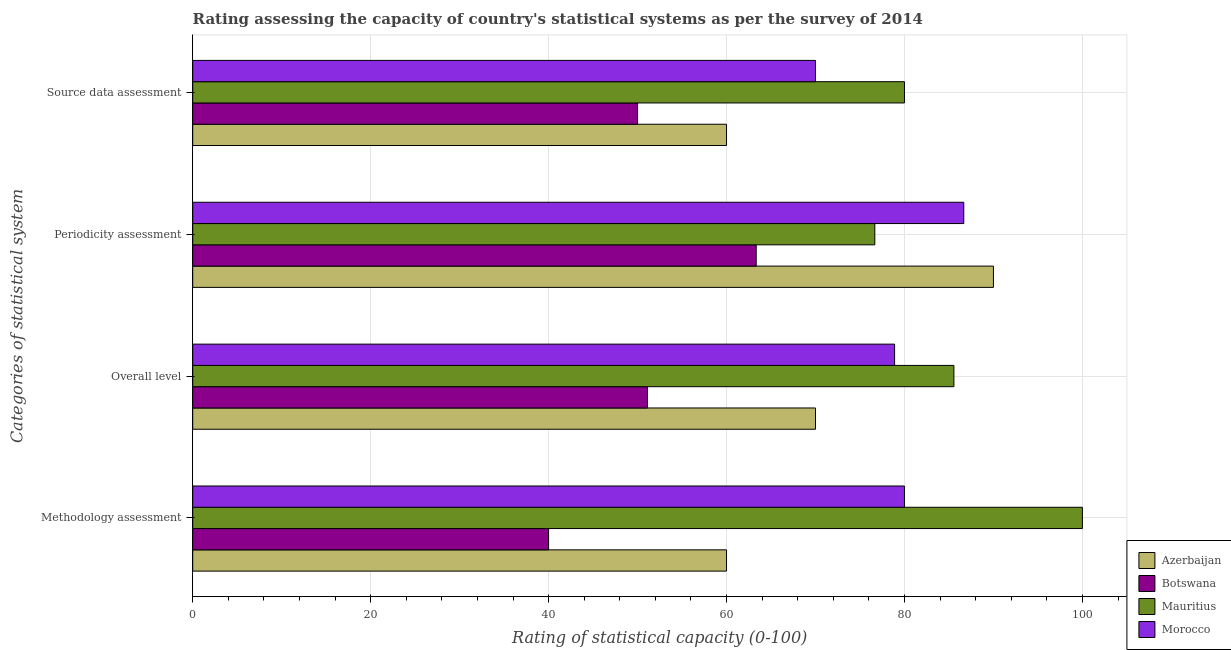Are the number of bars per tick equal to the number of legend labels?
Your answer should be very brief. Yes. Are the number of bars on each tick of the Y-axis equal?
Ensure brevity in your answer.  Yes. What is the label of the 1st group of bars from the top?
Offer a terse response. Source data assessment. What is the overall level rating in Botswana?
Make the answer very short. 51.11. Across all countries, what is the maximum overall level rating?
Provide a succinct answer. 85.56. Across all countries, what is the minimum source data assessment rating?
Provide a short and direct response. 50. In which country was the overall level rating maximum?
Offer a terse response. Mauritius. In which country was the methodology assessment rating minimum?
Ensure brevity in your answer.  Botswana. What is the total periodicity assessment rating in the graph?
Make the answer very short. 316.67. What is the difference between the source data assessment rating in Mauritius and that in Botswana?
Offer a terse response. 30. What is the difference between the overall level rating in Mauritius and the methodology assessment rating in Morocco?
Give a very brief answer. 5.56. What is the average methodology assessment rating per country?
Keep it short and to the point. 70. What is the difference between the periodicity assessment rating and overall level rating in Botswana?
Offer a terse response. 12.22. What is the ratio of the overall level rating in Mauritius to that in Morocco?
Provide a succinct answer. 1.08. Is the difference between the overall level rating in Azerbaijan and Botswana greater than the difference between the periodicity assessment rating in Azerbaijan and Botswana?
Provide a succinct answer. No. What is the difference between the highest and the second highest periodicity assessment rating?
Ensure brevity in your answer.  3.33. What is the difference between the highest and the lowest source data assessment rating?
Give a very brief answer. 30. In how many countries, is the source data assessment rating greater than the average source data assessment rating taken over all countries?
Provide a short and direct response. 2. What does the 2nd bar from the top in Periodicity assessment represents?
Make the answer very short. Mauritius. What does the 3rd bar from the bottom in Periodicity assessment represents?
Your answer should be very brief. Mauritius. Is it the case that in every country, the sum of the methodology assessment rating and overall level rating is greater than the periodicity assessment rating?
Your response must be concise. Yes. How many bars are there?
Give a very brief answer. 16. How many countries are there in the graph?
Ensure brevity in your answer.  4. Where does the legend appear in the graph?
Ensure brevity in your answer.  Bottom right. How many legend labels are there?
Keep it short and to the point. 4. How are the legend labels stacked?
Give a very brief answer. Vertical. What is the title of the graph?
Your response must be concise. Rating assessing the capacity of country's statistical systems as per the survey of 2014 . Does "Korea (Democratic)" appear as one of the legend labels in the graph?
Give a very brief answer. No. What is the label or title of the X-axis?
Provide a succinct answer. Rating of statistical capacity (0-100). What is the label or title of the Y-axis?
Your answer should be very brief. Categories of statistical system. What is the Rating of statistical capacity (0-100) of Botswana in Methodology assessment?
Offer a terse response. 40. What is the Rating of statistical capacity (0-100) in Mauritius in Methodology assessment?
Offer a terse response. 100. What is the Rating of statistical capacity (0-100) in Azerbaijan in Overall level?
Make the answer very short. 70. What is the Rating of statistical capacity (0-100) of Botswana in Overall level?
Your answer should be very brief. 51.11. What is the Rating of statistical capacity (0-100) in Mauritius in Overall level?
Your response must be concise. 85.56. What is the Rating of statistical capacity (0-100) in Morocco in Overall level?
Provide a short and direct response. 78.89. What is the Rating of statistical capacity (0-100) of Azerbaijan in Periodicity assessment?
Your answer should be compact. 90. What is the Rating of statistical capacity (0-100) of Botswana in Periodicity assessment?
Keep it short and to the point. 63.33. What is the Rating of statistical capacity (0-100) in Mauritius in Periodicity assessment?
Your answer should be compact. 76.67. What is the Rating of statistical capacity (0-100) in Morocco in Periodicity assessment?
Your answer should be very brief. 86.67. What is the Rating of statistical capacity (0-100) of Azerbaijan in Source data assessment?
Ensure brevity in your answer.  60. What is the Rating of statistical capacity (0-100) in Botswana in Source data assessment?
Make the answer very short. 50. What is the Rating of statistical capacity (0-100) in Mauritius in Source data assessment?
Offer a very short reply. 80. Across all Categories of statistical system, what is the maximum Rating of statistical capacity (0-100) of Botswana?
Your answer should be very brief. 63.33. Across all Categories of statistical system, what is the maximum Rating of statistical capacity (0-100) of Mauritius?
Give a very brief answer. 100. Across all Categories of statistical system, what is the maximum Rating of statistical capacity (0-100) in Morocco?
Provide a succinct answer. 86.67. Across all Categories of statistical system, what is the minimum Rating of statistical capacity (0-100) of Azerbaijan?
Make the answer very short. 60. Across all Categories of statistical system, what is the minimum Rating of statistical capacity (0-100) in Botswana?
Offer a very short reply. 40. Across all Categories of statistical system, what is the minimum Rating of statistical capacity (0-100) of Mauritius?
Offer a very short reply. 76.67. What is the total Rating of statistical capacity (0-100) of Azerbaijan in the graph?
Offer a very short reply. 280. What is the total Rating of statistical capacity (0-100) of Botswana in the graph?
Provide a succinct answer. 204.44. What is the total Rating of statistical capacity (0-100) in Mauritius in the graph?
Provide a succinct answer. 342.22. What is the total Rating of statistical capacity (0-100) of Morocco in the graph?
Keep it short and to the point. 315.56. What is the difference between the Rating of statistical capacity (0-100) in Azerbaijan in Methodology assessment and that in Overall level?
Your answer should be compact. -10. What is the difference between the Rating of statistical capacity (0-100) in Botswana in Methodology assessment and that in Overall level?
Provide a short and direct response. -11.11. What is the difference between the Rating of statistical capacity (0-100) in Mauritius in Methodology assessment and that in Overall level?
Keep it short and to the point. 14.44. What is the difference between the Rating of statistical capacity (0-100) in Azerbaijan in Methodology assessment and that in Periodicity assessment?
Make the answer very short. -30. What is the difference between the Rating of statistical capacity (0-100) of Botswana in Methodology assessment and that in Periodicity assessment?
Keep it short and to the point. -23.33. What is the difference between the Rating of statistical capacity (0-100) in Mauritius in Methodology assessment and that in Periodicity assessment?
Keep it short and to the point. 23.33. What is the difference between the Rating of statistical capacity (0-100) of Morocco in Methodology assessment and that in Periodicity assessment?
Offer a terse response. -6.67. What is the difference between the Rating of statistical capacity (0-100) in Azerbaijan in Methodology assessment and that in Source data assessment?
Keep it short and to the point. 0. What is the difference between the Rating of statistical capacity (0-100) in Mauritius in Methodology assessment and that in Source data assessment?
Offer a terse response. 20. What is the difference between the Rating of statistical capacity (0-100) in Morocco in Methodology assessment and that in Source data assessment?
Your answer should be very brief. 10. What is the difference between the Rating of statistical capacity (0-100) of Azerbaijan in Overall level and that in Periodicity assessment?
Make the answer very short. -20. What is the difference between the Rating of statistical capacity (0-100) in Botswana in Overall level and that in Periodicity assessment?
Your answer should be compact. -12.22. What is the difference between the Rating of statistical capacity (0-100) of Mauritius in Overall level and that in Periodicity assessment?
Your answer should be very brief. 8.89. What is the difference between the Rating of statistical capacity (0-100) of Morocco in Overall level and that in Periodicity assessment?
Your answer should be compact. -7.78. What is the difference between the Rating of statistical capacity (0-100) of Azerbaijan in Overall level and that in Source data assessment?
Make the answer very short. 10. What is the difference between the Rating of statistical capacity (0-100) in Mauritius in Overall level and that in Source data assessment?
Provide a succinct answer. 5.56. What is the difference between the Rating of statistical capacity (0-100) in Morocco in Overall level and that in Source data assessment?
Offer a very short reply. 8.89. What is the difference between the Rating of statistical capacity (0-100) of Azerbaijan in Periodicity assessment and that in Source data assessment?
Provide a succinct answer. 30. What is the difference between the Rating of statistical capacity (0-100) in Botswana in Periodicity assessment and that in Source data assessment?
Give a very brief answer. 13.33. What is the difference between the Rating of statistical capacity (0-100) in Morocco in Periodicity assessment and that in Source data assessment?
Provide a short and direct response. 16.67. What is the difference between the Rating of statistical capacity (0-100) in Azerbaijan in Methodology assessment and the Rating of statistical capacity (0-100) in Botswana in Overall level?
Keep it short and to the point. 8.89. What is the difference between the Rating of statistical capacity (0-100) of Azerbaijan in Methodology assessment and the Rating of statistical capacity (0-100) of Mauritius in Overall level?
Your answer should be compact. -25.56. What is the difference between the Rating of statistical capacity (0-100) of Azerbaijan in Methodology assessment and the Rating of statistical capacity (0-100) of Morocco in Overall level?
Keep it short and to the point. -18.89. What is the difference between the Rating of statistical capacity (0-100) of Botswana in Methodology assessment and the Rating of statistical capacity (0-100) of Mauritius in Overall level?
Ensure brevity in your answer.  -45.56. What is the difference between the Rating of statistical capacity (0-100) in Botswana in Methodology assessment and the Rating of statistical capacity (0-100) in Morocco in Overall level?
Your response must be concise. -38.89. What is the difference between the Rating of statistical capacity (0-100) of Mauritius in Methodology assessment and the Rating of statistical capacity (0-100) of Morocco in Overall level?
Ensure brevity in your answer.  21.11. What is the difference between the Rating of statistical capacity (0-100) of Azerbaijan in Methodology assessment and the Rating of statistical capacity (0-100) of Mauritius in Periodicity assessment?
Keep it short and to the point. -16.67. What is the difference between the Rating of statistical capacity (0-100) in Azerbaijan in Methodology assessment and the Rating of statistical capacity (0-100) in Morocco in Periodicity assessment?
Give a very brief answer. -26.67. What is the difference between the Rating of statistical capacity (0-100) of Botswana in Methodology assessment and the Rating of statistical capacity (0-100) of Mauritius in Periodicity assessment?
Your response must be concise. -36.67. What is the difference between the Rating of statistical capacity (0-100) of Botswana in Methodology assessment and the Rating of statistical capacity (0-100) of Morocco in Periodicity assessment?
Keep it short and to the point. -46.67. What is the difference between the Rating of statistical capacity (0-100) of Mauritius in Methodology assessment and the Rating of statistical capacity (0-100) of Morocco in Periodicity assessment?
Offer a very short reply. 13.33. What is the difference between the Rating of statistical capacity (0-100) of Azerbaijan in Methodology assessment and the Rating of statistical capacity (0-100) of Mauritius in Source data assessment?
Provide a succinct answer. -20. What is the difference between the Rating of statistical capacity (0-100) of Azerbaijan in Methodology assessment and the Rating of statistical capacity (0-100) of Morocco in Source data assessment?
Keep it short and to the point. -10. What is the difference between the Rating of statistical capacity (0-100) of Botswana in Methodology assessment and the Rating of statistical capacity (0-100) of Mauritius in Source data assessment?
Give a very brief answer. -40. What is the difference between the Rating of statistical capacity (0-100) in Botswana in Methodology assessment and the Rating of statistical capacity (0-100) in Morocco in Source data assessment?
Keep it short and to the point. -30. What is the difference between the Rating of statistical capacity (0-100) of Mauritius in Methodology assessment and the Rating of statistical capacity (0-100) of Morocco in Source data assessment?
Keep it short and to the point. 30. What is the difference between the Rating of statistical capacity (0-100) of Azerbaijan in Overall level and the Rating of statistical capacity (0-100) of Mauritius in Periodicity assessment?
Offer a very short reply. -6.67. What is the difference between the Rating of statistical capacity (0-100) in Azerbaijan in Overall level and the Rating of statistical capacity (0-100) in Morocco in Periodicity assessment?
Provide a short and direct response. -16.67. What is the difference between the Rating of statistical capacity (0-100) of Botswana in Overall level and the Rating of statistical capacity (0-100) of Mauritius in Periodicity assessment?
Keep it short and to the point. -25.56. What is the difference between the Rating of statistical capacity (0-100) of Botswana in Overall level and the Rating of statistical capacity (0-100) of Morocco in Periodicity assessment?
Provide a succinct answer. -35.56. What is the difference between the Rating of statistical capacity (0-100) in Mauritius in Overall level and the Rating of statistical capacity (0-100) in Morocco in Periodicity assessment?
Provide a short and direct response. -1.11. What is the difference between the Rating of statistical capacity (0-100) of Botswana in Overall level and the Rating of statistical capacity (0-100) of Mauritius in Source data assessment?
Provide a succinct answer. -28.89. What is the difference between the Rating of statistical capacity (0-100) in Botswana in Overall level and the Rating of statistical capacity (0-100) in Morocco in Source data assessment?
Your response must be concise. -18.89. What is the difference between the Rating of statistical capacity (0-100) of Mauritius in Overall level and the Rating of statistical capacity (0-100) of Morocco in Source data assessment?
Your answer should be very brief. 15.56. What is the difference between the Rating of statistical capacity (0-100) in Botswana in Periodicity assessment and the Rating of statistical capacity (0-100) in Mauritius in Source data assessment?
Ensure brevity in your answer.  -16.67. What is the difference between the Rating of statistical capacity (0-100) of Botswana in Periodicity assessment and the Rating of statistical capacity (0-100) of Morocco in Source data assessment?
Provide a short and direct response. -6.67. What is the difference between the Rating of statistical capacity (0-100) in Mauritius in Periodicity assessment and the Rating of statistical capacity (0-100) in Morocco in Source data assessment?
Give a very brief answer. 6.67. What is the average Rating of statistical capacity (0-100) in Botswana per Categories of statistical system?
Your answer should be compact. 51.11. What is the average Rating of statistical capacity (0-100) of Mauritius per Categories of statistical system?
Your response must be concise. 85.56. What is the average Rating of statistical capacity (0-100) of Morocco per Categories of statistical system?
Ensure brevity in your answer.  78.89. What is the difference between the Rating of statistical capacity (0-100) in Azerbaijan and Rating of statistical capacity (0-100) in Morocco in Methodology assessment?
Keep it short and to the point. -20. What is the difference between the Rating of statistical capacity (0-100) of Botswana and Rating of statistical capacity (0-100) of Mauritius in Methodology assessment?
Your response must be concise. -60. What is the difference between the Rating of statistical capacity (0-100) of Azerbaijan and Rating of statistical capacity (0-100) of Botswana in Overall level?
Keep it short and to the point. 18.89. What is the difference between the Rating of statistical capacity (0-100) of Azerbaijan and Rating of statistical capacity (0-100) of Mauritius in Overall level?
Give a very brief answer. -15.56. What is the difference between the Rating of statistical capacity (0-100) of Azerbaijan and Rating of statistical capacity (0-100) of Morocco in Overall level?
Your answer should be very brief. -8.89. What is the difference between the Rating of statistical capacity (0-100) in Botswana and Rating of statistical capacity (0-100) in Mauritius in Overall level?
Keep it short and to the point. -34.44. What is the difference between the Rating of statistical capacity (0-100) in Botswana and Rating of statistical capacity (0-100) in Morocco in Overall level?
Give a very brief answer. -27.78. What is the difference between the Rating of statistical capacity (0-100) in Azerbaijan and Rating of statistical capacity (0-100) in Botswana in Periodicity assessment?
Provide a succinct answer. 26.67. What is the difference between the Rating of statistical capacity (0-100) in Azerbaijan and Rating of statistical capacity (0-100) in Mauritius in Periodicity assessment?
Your answer should be compact. 13.33. What is the difference between the Rating of statistical capacity (0-100) in Azerbaijan and Rating of statistical capacity (0-100) in Morocco in Periodicity assessment?
Ensure brevity in your answer.  3.33. What is the difference between the Rating of statistical capacity (0-100) in Botswana and Rating of statistical capacity (0-100) in Mauritius in Periodicity assessment?
Make the answer very short. -13.33. What is the difference between the Rating of statistical capacity (0-100) of Botswana and Rating of statistical capacity (0-100) of Morocco in Periodicity assessment?
Your answer should be compact. -23.33. What is the difference between the Rating of statistical capacity (0-100) of Mauritius and Rating of statistical capacity (0-100) of Morocco in Periodicity assessment?
Offer a terse response. -10. What is the difference between the Rating of statistical capacity (0-100) of Azerbaijan and Rating of statistical capacity (0-100) of Botswana in Source data assessment?
Your response must be concise. 10. What is the difference between the Rating of statistical capacity (0-100) of Botswana and Rating of statistical capacity (0-100) of Morocco in Source data assessment?
Ensure brevity in your answer.  -20. What is the ratio of the Rating of statistical capacity (0-100) in Azerbaijan in Methodology assessment to that in Overall level?
Provide a succinct answer. 0.86. What is the ratio of the Rating of statistical capacity (0-100) in Botswana in Methodology assessment to that in Overall level?
Offer a terse response. 0.78. What is the ratio of the Rating of statistical capacity (0-100) of Mauritius in Methodology assessment to that in Overall level?
Your answer should be compact. 1.17. What is the ratio of the Rating of statistical capacity (0-100) in Morocco in Methodology assessment to that in Overall level?
Make the answer very short. 1.01. What is the ratio of the Rating of statistical capacity (0-100) of Azerbaijan in Methodology assessment to that in Periodicity assessment?
Offer a terse response. 0.67. What is the ratio of the Rating of statistical capacity (0-100) in Botswana in Methodology assessment to that in Periodicity assessment?
Ensure brevity in your answer.  0.63. What is the ratio of the Rating of statistical capacity (0-100) of Mauritius in Methodology assessment to that in Periodicity assessment?
Your answer should be compact. 1.3. What is the ratio of the Rating of statistical capacity (0-100) in Morocco in Methodology assessment to that in Source data assessment?
Provide a short and direct response. 1.14. What is the ratio of the Rating of statistical capacity (0-100) of Azerbaijan in Overall level to that in Periodicity assessment?
Keep it short and to the point. 0.78. What is the ratio of the Rating of statistical capacity (0-100) in Botswana in Overall level to that in Periodicity assessment?
Give a very brief answer. 0.81. What is the ratio of the Rating of statistical capacity (0-100) in Mauritius in Overall level to that in Periodicity assessment?
Provide a succinct answer. 1.12. What is the ratio of the Rating of statistical capacity (0-100) in Morocco in Overall level to that in Periodicity assessment?
Offer a terse response. 0.91. What is the ratio of the Rating of statistical capacity (0-100) in Azerbaijan in Overall level to that in Source data assessment?
Your answer should be very brief. 1.17. What is the ratio of the Rating of statistical capacity (0-100) of Botswana in Overall level to that in Source data assessment?
Your response must be concise. 1.02. What is the ratio of the Rating of statistical capacity (0-100) of Mauritius in Overall level to that in Source data assessment?
Your response must be concise. 1.07. What is the ratio of the Rating of statistical capacity (0-100) in Morocco in Overall level to that in Source data assessment?
Give a very brief answer. 1.13. What is the ratio of the Rating of statistical capacity (0-100) in Botswana in Periodicity assessment to that in Source data assessment?
Provide a succinct answer. 1.27. What is the ratio of the Rating of statistical capacity (0-100) of Mauritius in Periodicity assessment to that in Source data assessment?
Provide a succinct answer. 0.96. What is the ratio of the Rating of statistical capacity (0-100) in Morocco in Periodicity assessment to that in Source data assessment?
Your response must be concise. 1.24. What is the difference between the highest and the second highest Rating of statistical capacity (0-100) in Azerbaijan?
Keep it short and to the point. 20. What is the difference between the highest and the second highest Rating of statistical capacity (0-100) of Botswana?
Keep it short and to the point. 12.22. What is the difference between the highest and the second highest Rating of statistical capacity (0-100) in Mauritius?
Give a very brief answer. 14.44. What is the difference between the highest and the lowest Rating of statistical capacity (0-100) in Azerbaijan?
Your answer should be compact. 30. What is the difference between the highest and the lowest Rating of statistical capacity (0-100) in Botswana?
Your response must be concise. 23.33. What is the difference between the highest and the lowest Rating of statistical capacity (0-100) in Mauritius?
Offer a terse response. 23.33. What is the difference between the highest and the lowest Rating of statistical capacity (0-100) in Morocco?
Provide a short and direct response. 16.67. 